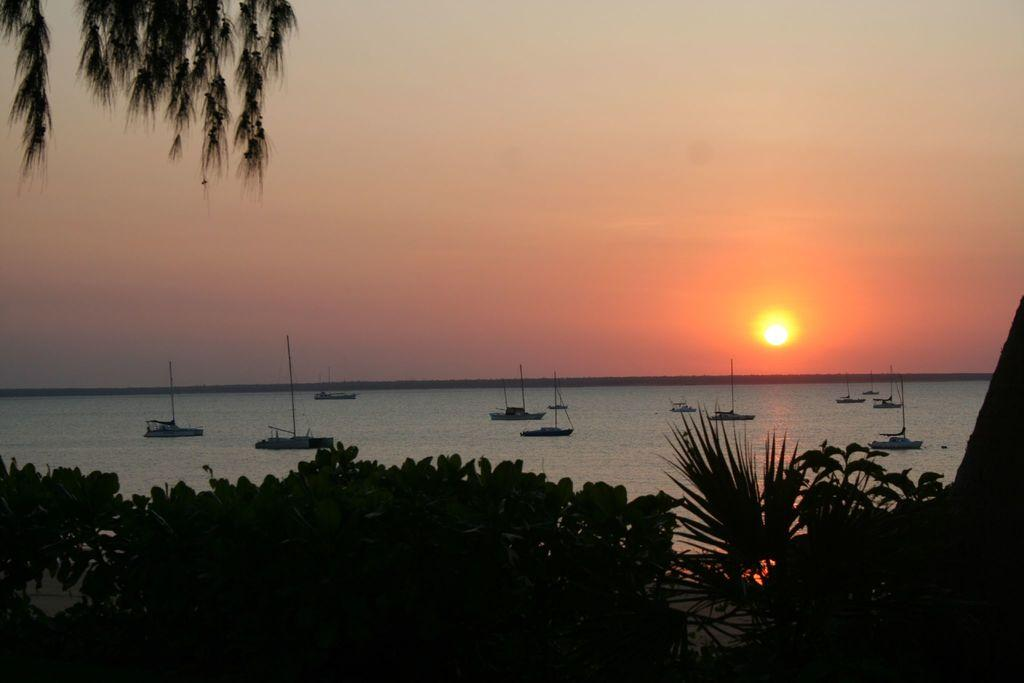What type of vegetation can be seen in the image? There are trees in the image. What can be seen on the water in the background? There are boats visible on the water in the background. What is the primary body of water in the image? The water is visible in the image. What is visible in the sky in the image? The sky is visible in the image, and the sun is also visible. What company is responsible for the sail in the image? There is no sail present in the image, and therefore no company is associated with it. 